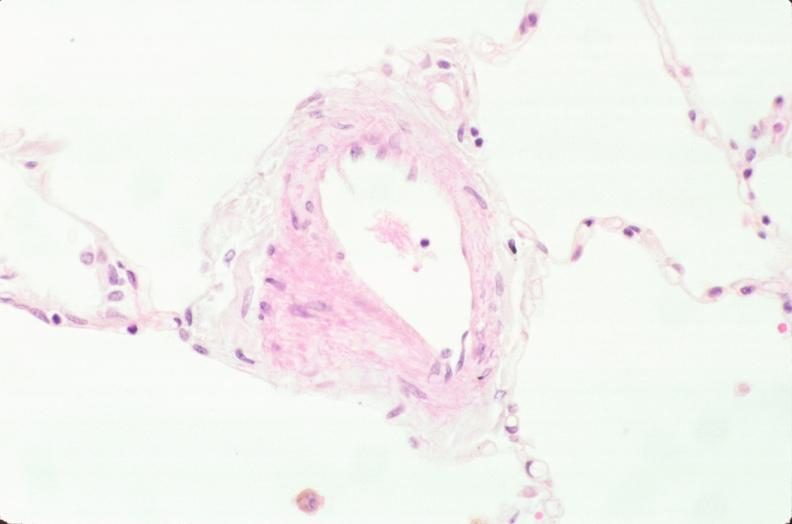does this image show lung, phlebosclerosis?
Answer the question using a single word or phrase. Yes 